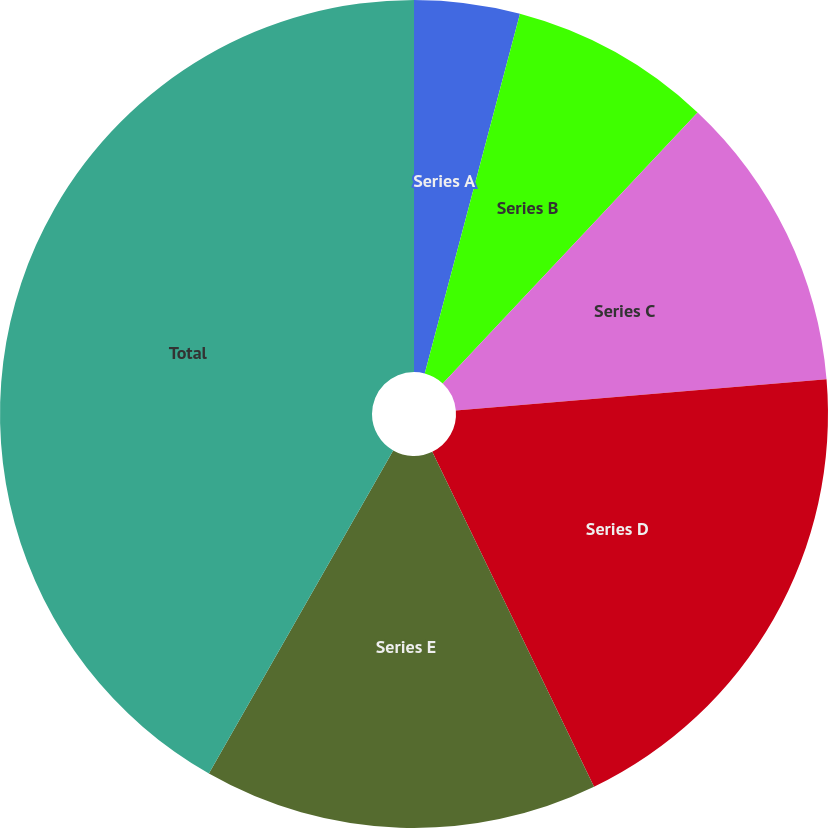<chart> <loc_0><loc_0><loc_500><loc_500><pie_chart><fcel>Series A<fcel>Series B<fcel>Series C<fcel>Series D<fcel>Series E<fcel>Total<nl><fcel>4.12%<fcel>7.89%<fcel>11.65%<fcel>19.18%<fcel>15.41%<fcel>41.75%<nl></chart> 